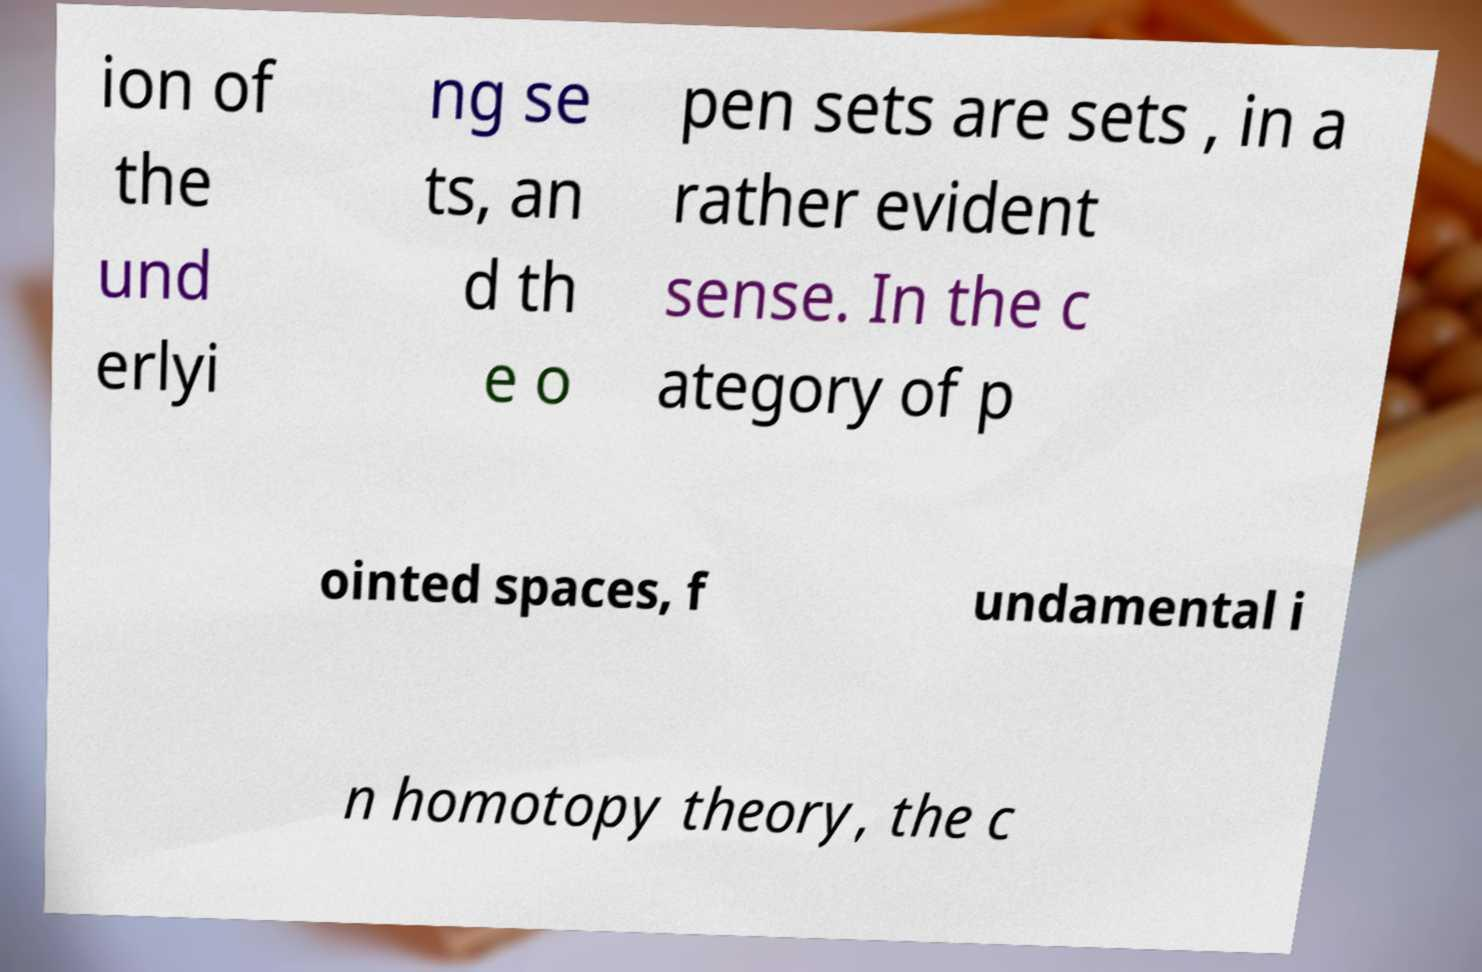For documentation purposes, I need the text within this image transcribed. Could you provide that? ion of the und erlyi ng se ts, an d th e o pen sets are sets , in a rather evident sense. In the c ategory of p ointed spaces, f undamental i n homotopy theory, the c 